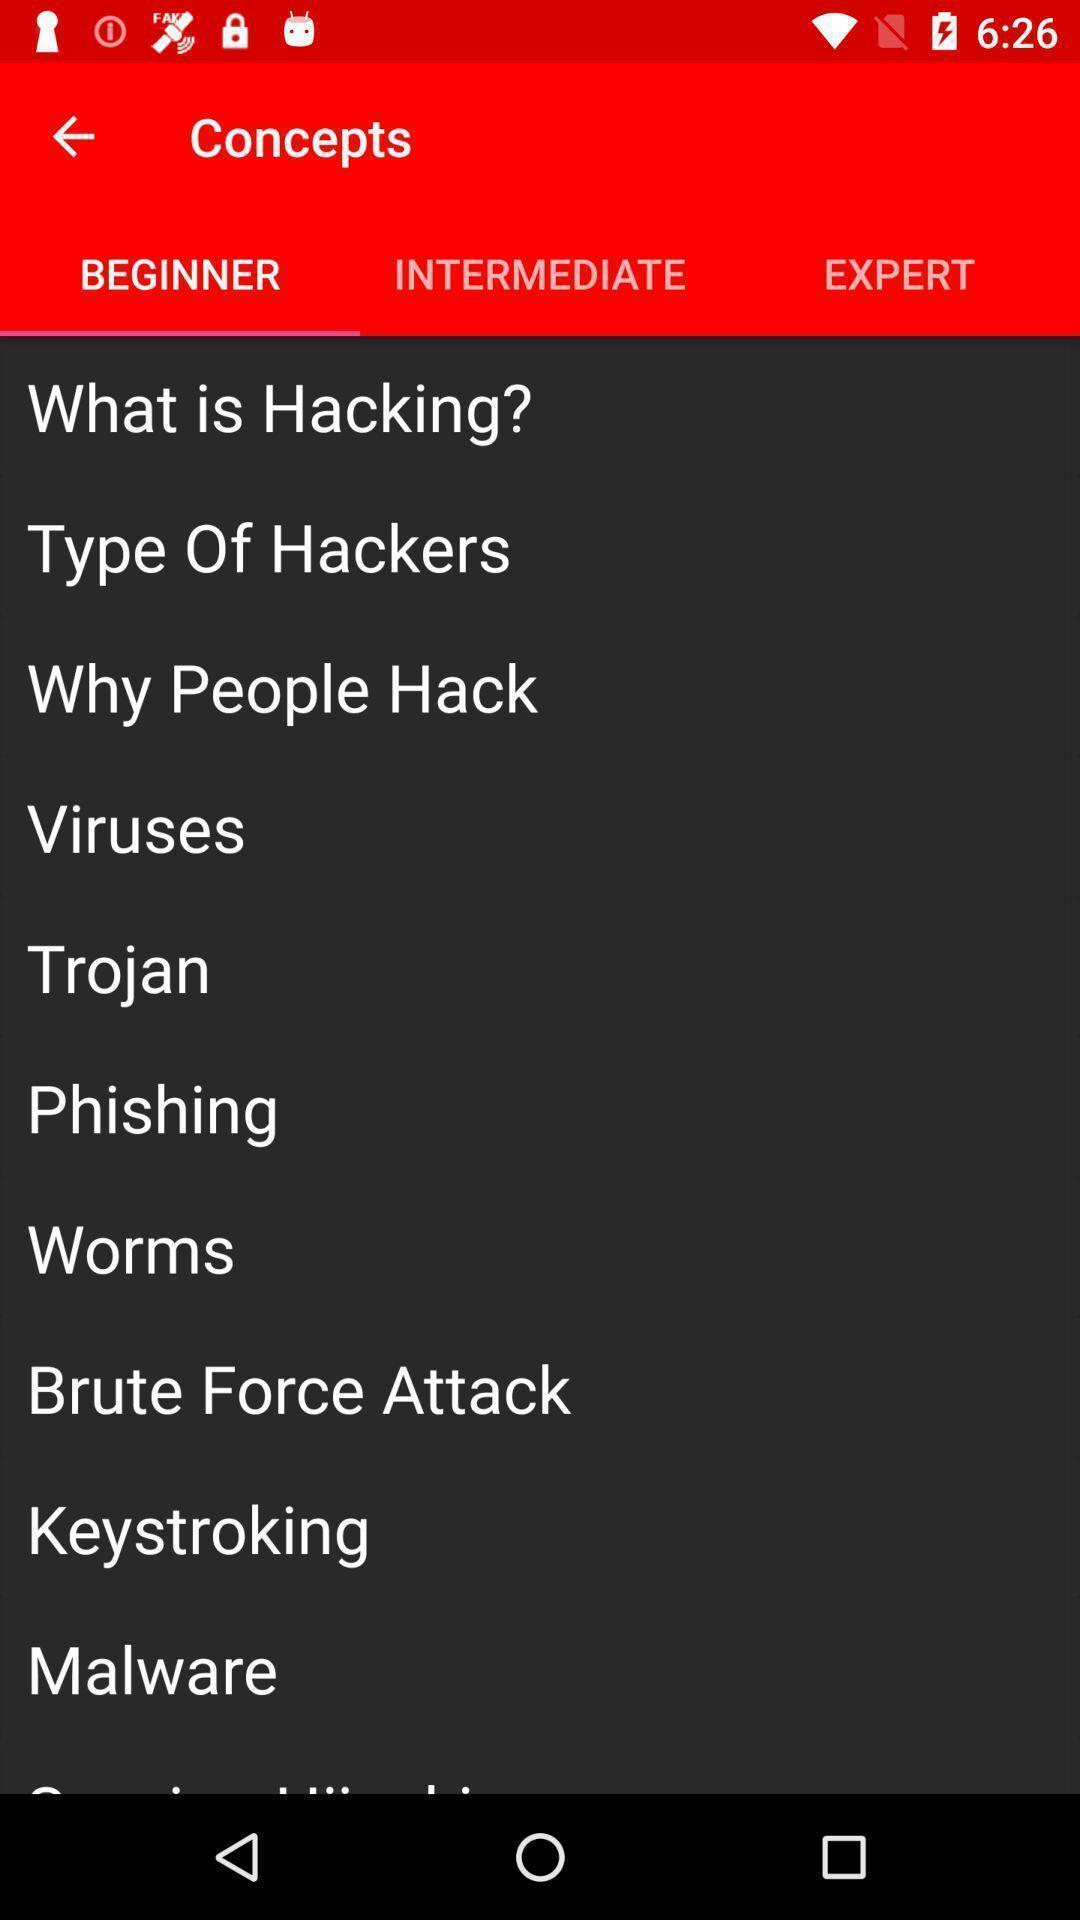Provide a description of this screenshot. Page displaying the concepts in a hacking learning app. 